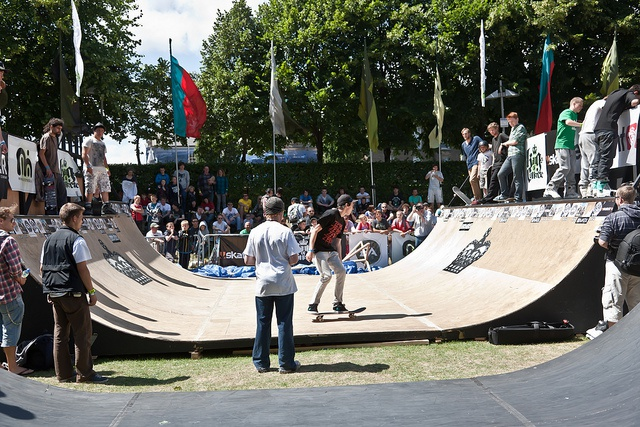Describe the objects in this image and their specific colors. I can see people in black, gray, darkgray, and lightgray tones, people in black, gray, darkgray, and maroon tones, people in black, white, and gray tones, people in black, gray, white, and darkgray tones, and people in black, gray, white, and darkgray tones in this image. 